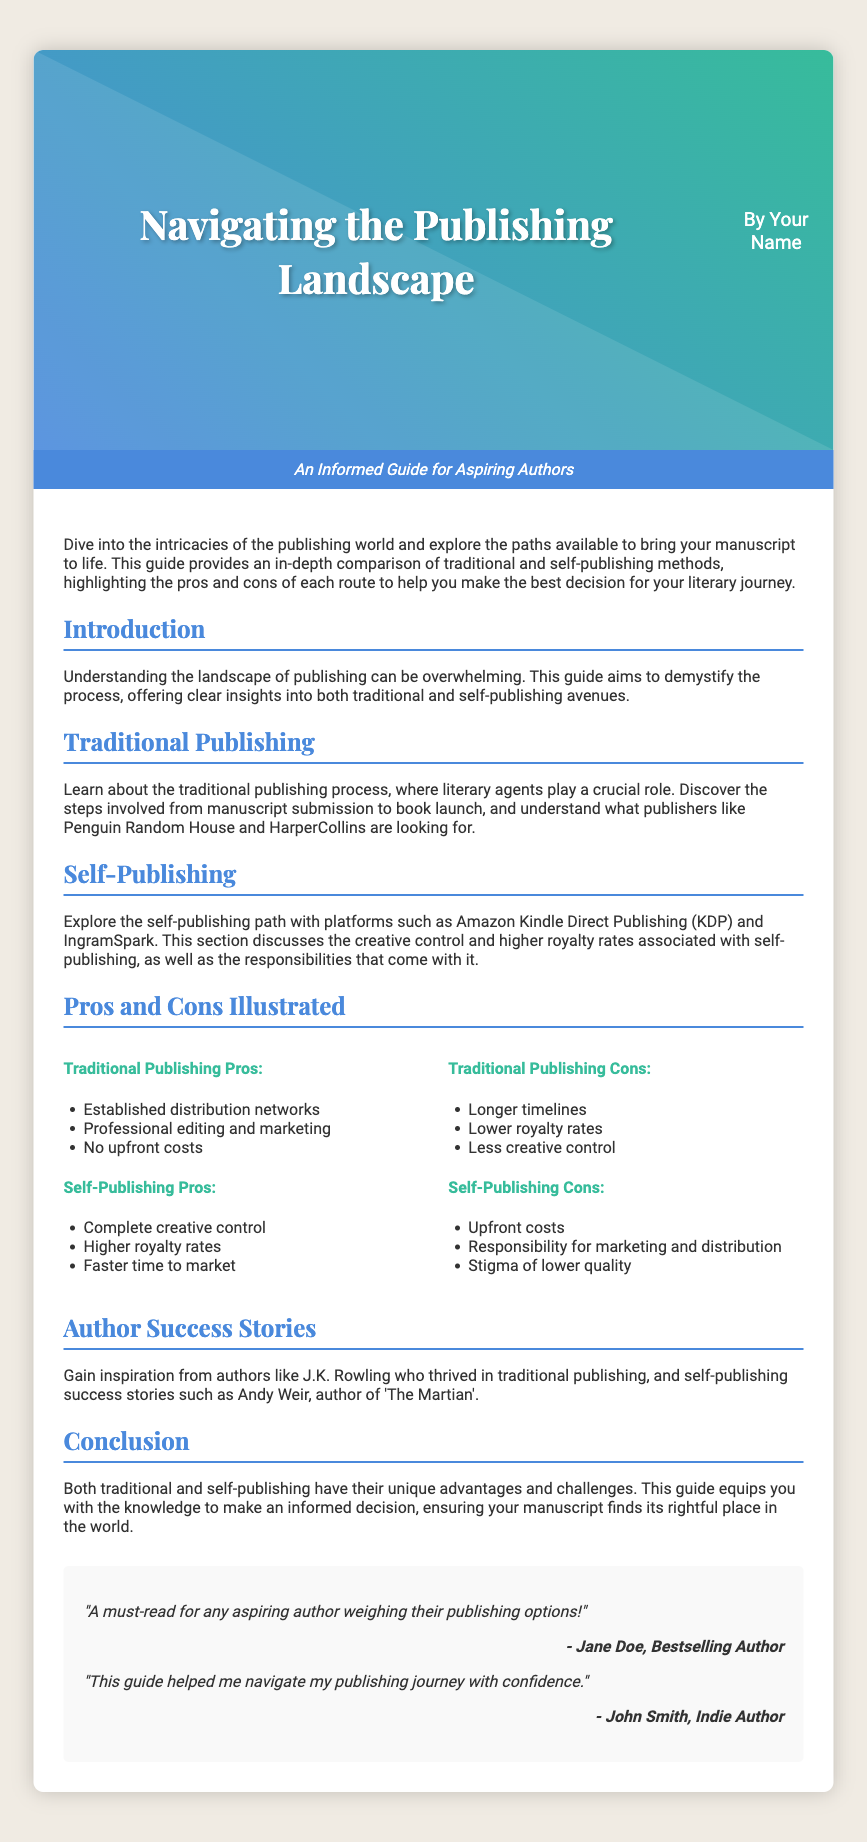What is the title of the book? The title of the book is displayed prominently in the cover image section.
Answer: Navigating the Publishing Landscape Who is the author of the book? The author's name is found just below the title in the cover image section.
Answer: Your Name What are the two main publishing methods discussed? The document highlights two primary publishing methods in the content sections.
Answer: Traditional and self-publishing What platform is mentioned for self-publishing? The document provides an example of a self-publishing platform in the self-publishing section.
Answer: Amazon Kindle Direct Publishing (KDP) How many pros are listed for traditional publishing? The document details the advantages in the pros section for traditional publishing.
Answer: Three What is one con of self-publishing? The document lists disadvantages in the cons section for self-publishing.
Answer: Upfront costs Who is one author mentioned as a traditional publishing success story? The conclusion section references successful authors in the context of publishing methods.
Answer: J.K. Rowling What is the tagline of the book? The tagline provides a summary of the book's purpose and is displayed under the cover image.
Answer: An Informed Guide for Aspiring Authors What benefit is associated with self-publishing regarding royalty rates? The document explains financial advantages in the self-publishing pros section.
Answer: Higher royalty rates 